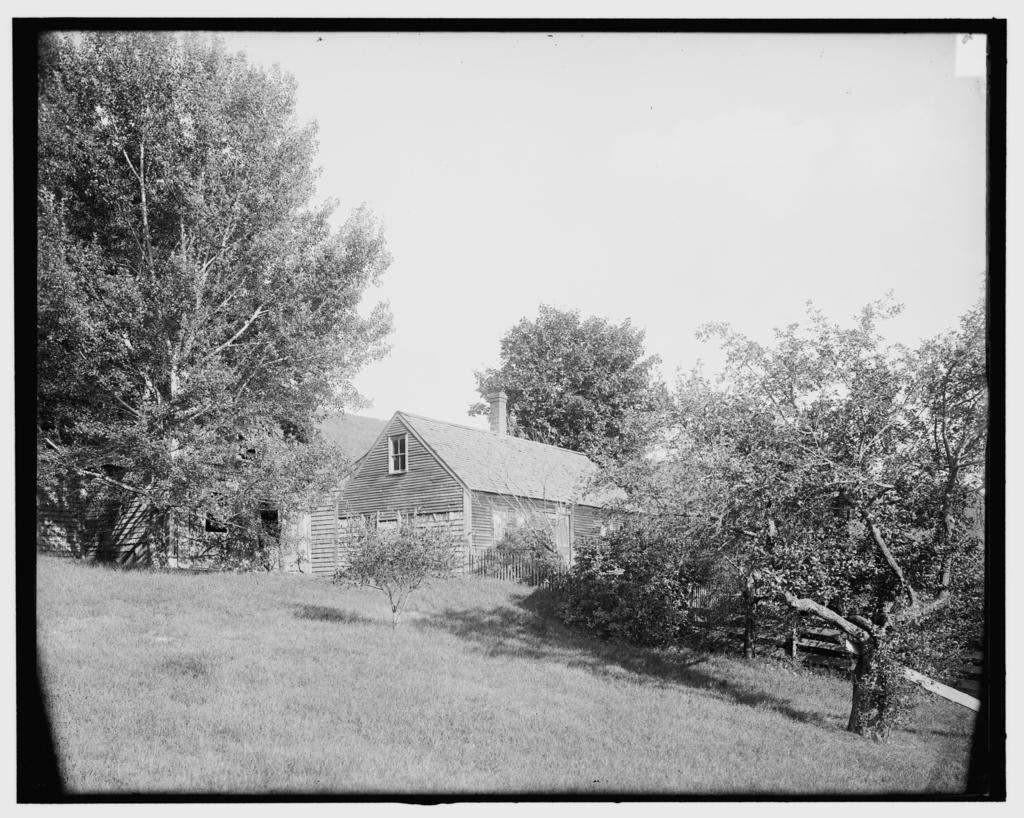What type of vegetation can be seen in the background of the image? There are trees in the background of the image. What type of structure is visible in the background of the image? There is a house in the background of the image. What type of ground cover is present in the center of the image? There is grass in the center of the image. What theory is being discussed by the servant during their journey in the image? There is no servant or journey present in the image, and therefore no such discussion can be observed. 